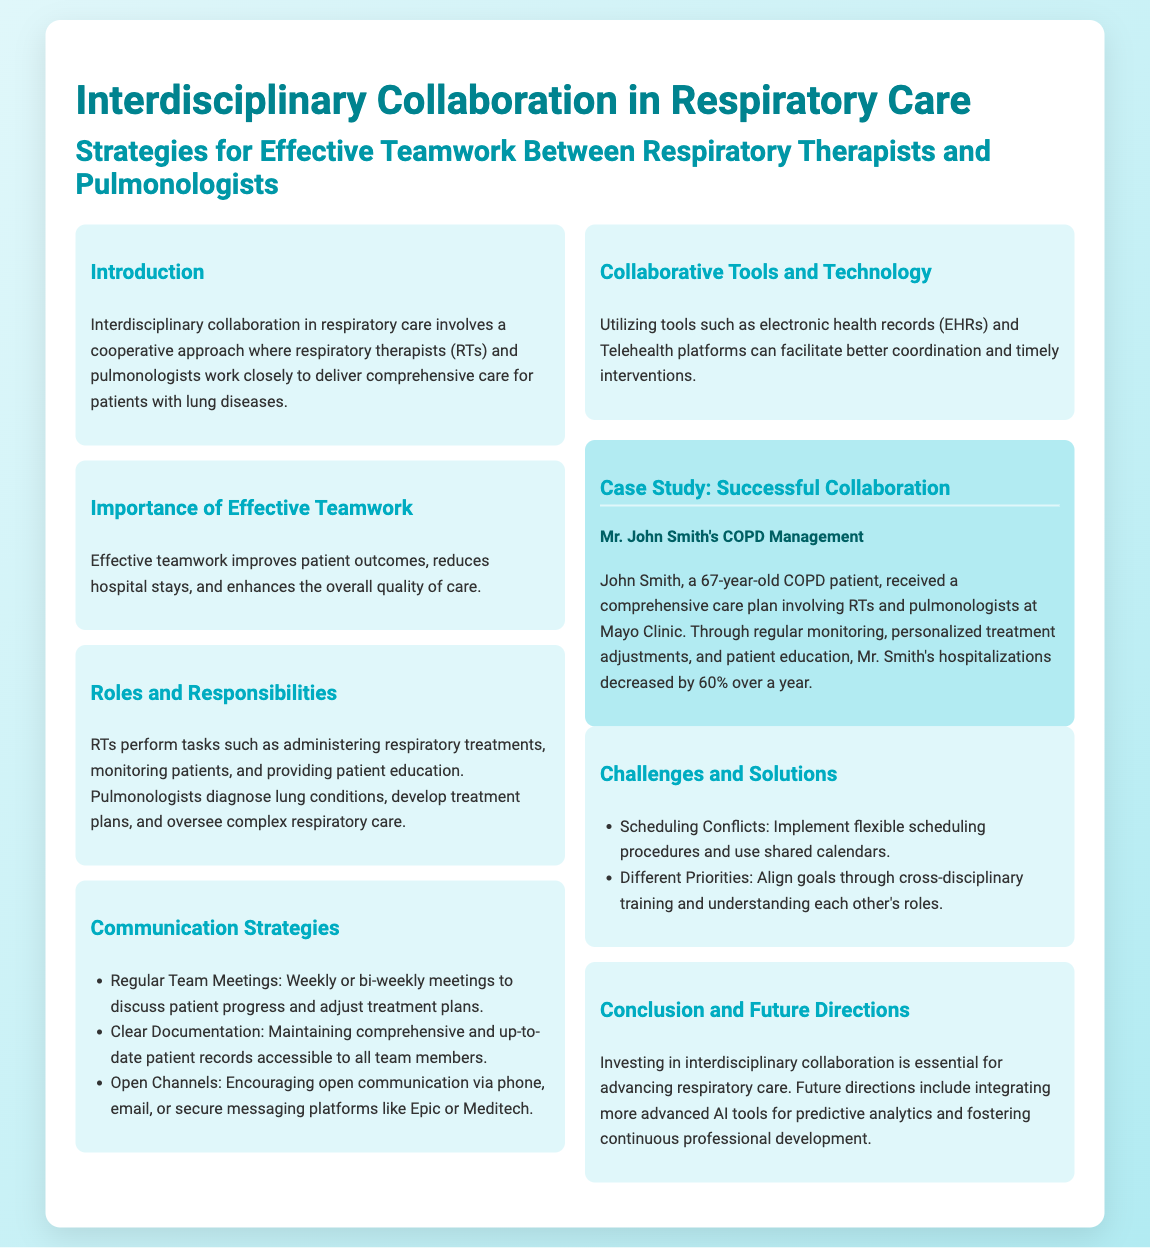What is the main focus of interdisciplinary collaboration in respiratory care? The main focus is a cooperative approach where respiratory therapists and pulmonologists work closely to deliver comprehensive care for patients with lung diseases.
Answer: Comprehensive care for patients with lung diseases What are the benefits of effective teamwork according to the document? The benefits include improved patient outcomes, reduced hospital stays, and enhanced overall quality of care.
Answer: Improved patient outcomes, reduced hospital stays, enhanced overall quality of care What task do respiratory therapists perform? Respiratory therapists perform tasks such as administering respiratory treatments, monitoring patients, and providing patient education.
Answer: Administering respiratory treatments What is one suggested communication strategy for the team? One suggested communication strategy is regular team meetings.
Answer: Regular team meetings Which technology is mentioned as a tool for better coordination? Electronic health records (EHRs) are mentioned as a tool for better coordination.
Answer: Electronic health records (EHRs) What is the percentage decrease in hospitalizations for Mr. John Smith? Mr. John Smith's hospitalizations decreased by 60% over a year.
Answer: 60% What flexible procedure is recommended to address scheduling conflicts? Implement flexible scheduling procedures is the recommended solution.
Answer: Flexible scheduling procedures What is one future direction for respiratory care? One future direction is integrating more advanced AI tools for predictive analytics.
Answer: Advanced AI tools for predictive analytics 